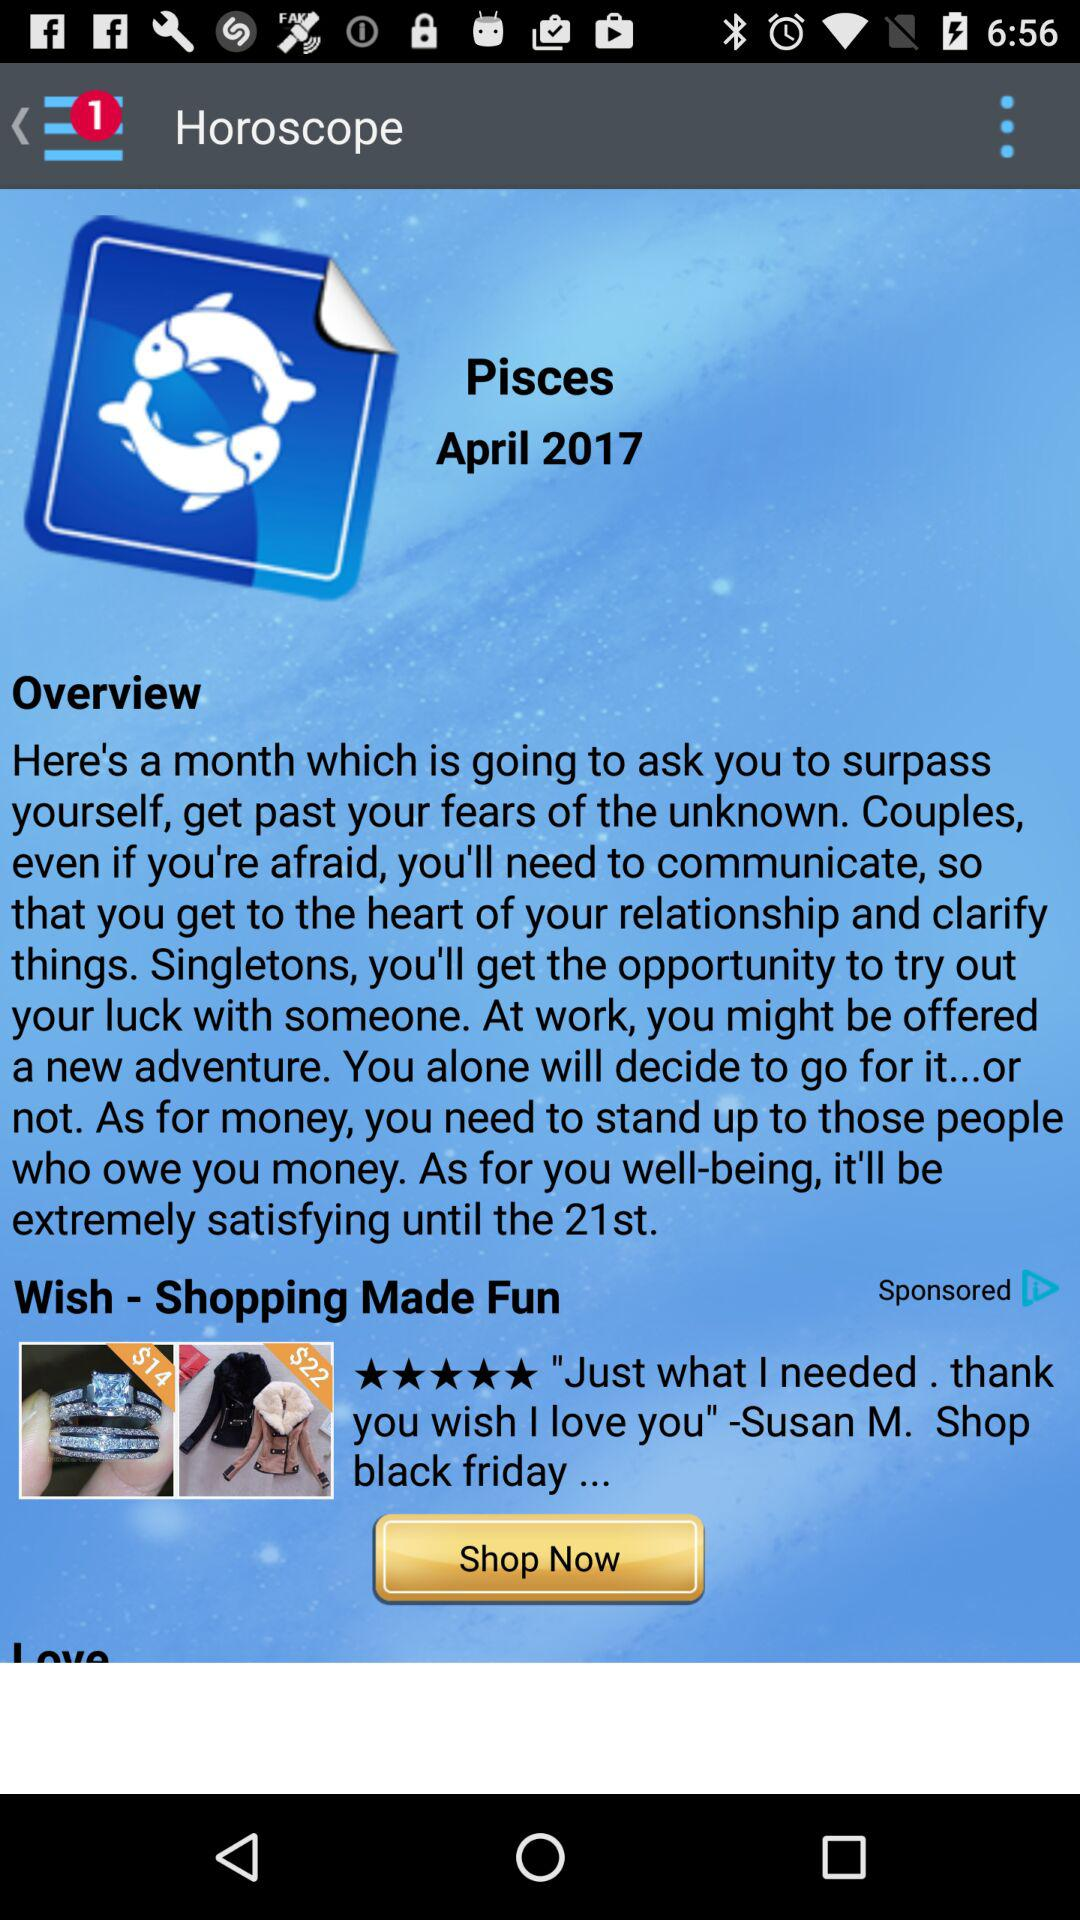What is the horoscope date for Pisces? The date is April 21, 2017. 